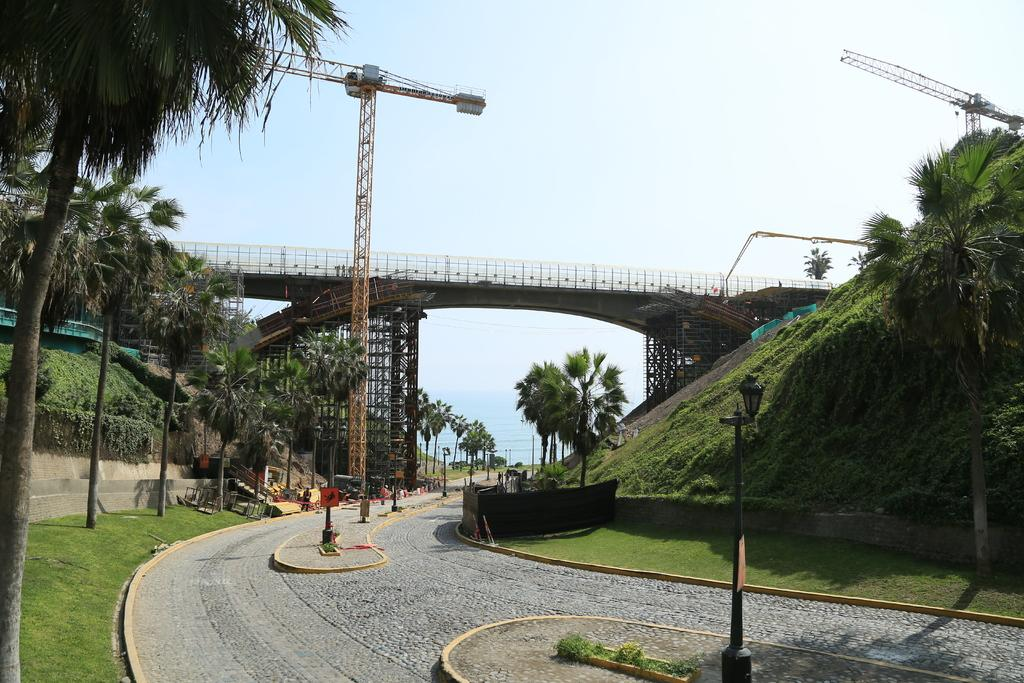What type of water feature can be seen in the image? There are pools in the image. What can be used to illuminate the area in the image? There is a light in the image. What can be observed due to the presence of the light in the image? Shadows are visible in the image. What type of vegetation is present in the image? There is grass and trees in the image. What part of the natural environment is visible in the image? The sky is visible in the image. What is the purpose of the board in the image? The purpose of the board in the image is not specified, but it could be used for signage or as a surface for writing or drawing. What type of construction equipment can be seen in the image? There are yellow color cranes in the image. What type of soda is being served in the image? There is no soda present in the image. What level of difficulty is indicated by the board in the image? The board in the image does not indicate a level of difficulty; it is not a game or challenge. 